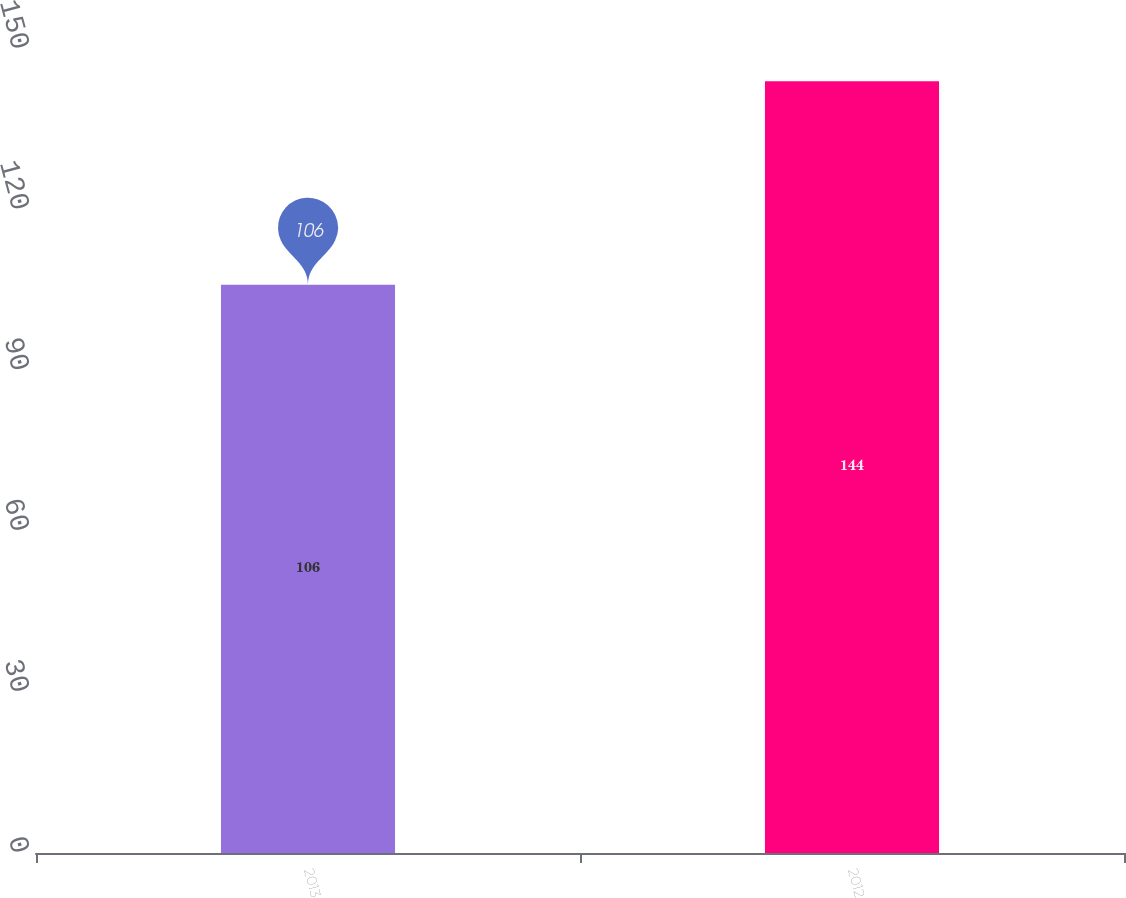Convert chart to OTSL. <chart><loc_0><loc_0><loc_500><loc_500><bar_chart><fcel>2013<fcel>2012<nl><fcel>106<fcel>144<nl></chart> 